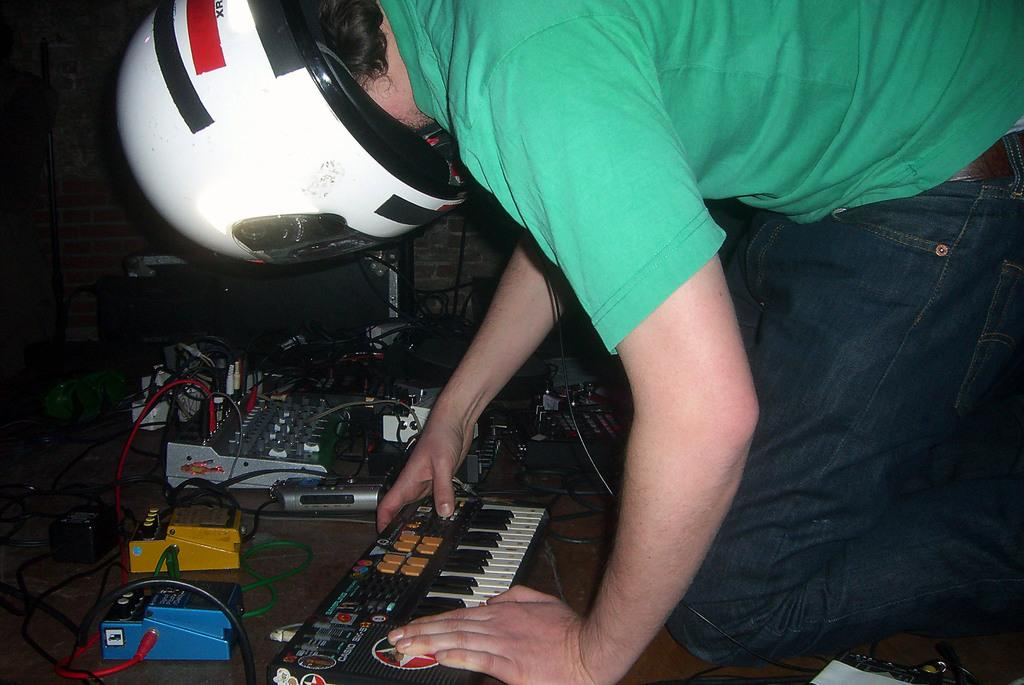What is the person in the image wearing on their upper body? The person is wearing a green t-shirt. What is the person wearing on their lower body? The person is wearing blue jeans. What type of protective gear is the person wearing? The person is wearing a helmet. What activity is the person engaged in? The person is operating a piano. What can be seen in the background of the image? There is electronic equipment in the background of the image. Can you see any flowers in the image? There are no flowers visible in the image. How does the person in the image kiss the hole in the wall? There is no hole in the wall or any indication of a kiss in the image. 